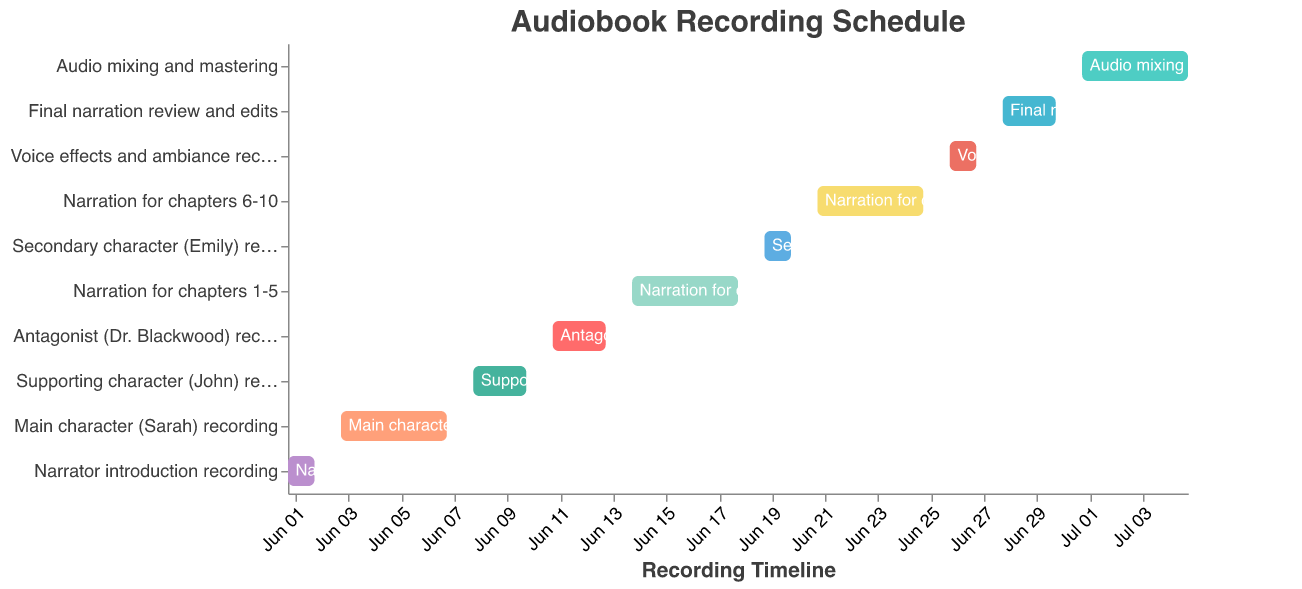What is the title of the figure? The title is usually at the top of the figure. In this case, it is clearly marked as the heading in the data.
Answer: Audiobook Recording Schedule Which recording task starts first? The task with the earliest "Start Date" will be the first one. From the data, "Narrator introduction recording" starts on 2023-06-01, the earliest date.
Answer: Narrator introduction recording How many days are allocated for "Narration for chapters 1-5"? To find the number of days, calculate the difference between the "End Date" and "Start Date". For "Narration for chapters 1-5", it starts on 2023-06-14 and ends on 2023-06-18. The duration is 5 days (including both start and end dates).
Answer: 5 days Which task overlaps with the "Secondary character (Emily) recording"? Check for any tasks that have a timeline that intersects the "Secondary character (Emily) recording" timeline (2023-06-19 to 2023-06-20). "Narration for chapters 6-10" overlaps as it goes from 2023-06-21 to 2023-06-25.
Answer: None What is the total duration of all narration-related tasks? Sum up the duration of tasks that have "Narration" in their titles. "Narration for chapters 1-5" (5 days), "Narration for chapters 6-10" (5 days), and "Final narration review and edits" (3 days). Adding those gives 5 + 5 + 3 = 13 days.
Answer: 13 days Which character's recording spans the most days? Compare the duration (End Date - Start Date) for each character. The options are Sarah (5 days), John (3 days), Dr. Blackwood (3 days), and Emily (2 days). Sarah's recording spans the most days.
Answer: Main character (Sarah) recording In which month does the "Audio mixing and mastering" task take place? Check the Start Date and End Date for the "Audio mixing and mastering" task; it starts on 2023-07-01 and ends on 2023-07-05. This entire duration falls in July.
Answer: July Which task follows the "Supporting character (John) recording"? Identify the task that begins immediately after the "Supporting character (John) recording" ends. John’s recording ends on 2023-06-10 and the next task, "Antagonist (Dr. Blackwood) recording", starts on 2023-06-11.
Answer: Antagonist (Dr. Blackwood) recording Which task starts on June 21st, 2023? Look at the Start Dates to find the task that begins specifically on 2023-06-21. This is "Narration for chapters 6-10".
Answer: Narration for chapters 6-10 How many tasks are there in total? Count the total number of distinct tasks listed in the data. There are 10 tasks in total.
Answer: 10 tasks 